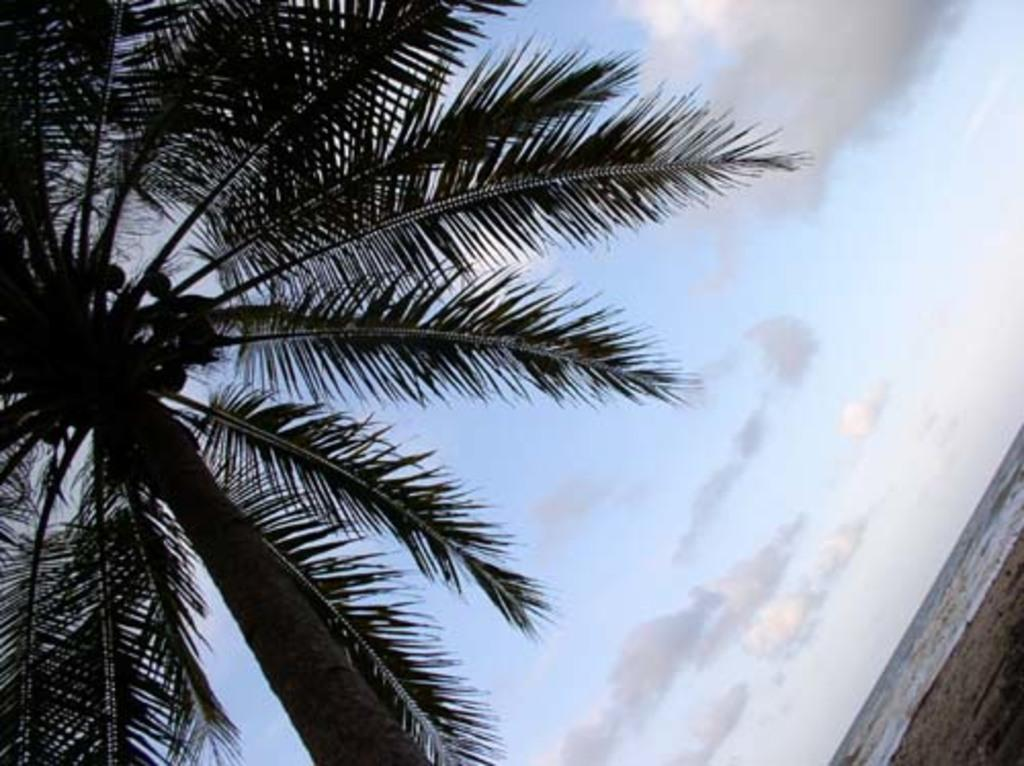What type of tree is present in the image? There is a tree with coconuts in the image. What else can be seen in the image besides the tree? Water is visible in the image. What is visible in the background of the image? The sky with clouds is present in the background of the image. How many eyes can be seen on the tree in the image? There are no eyes present on the tree in the image; it is a tree with coconuts. 